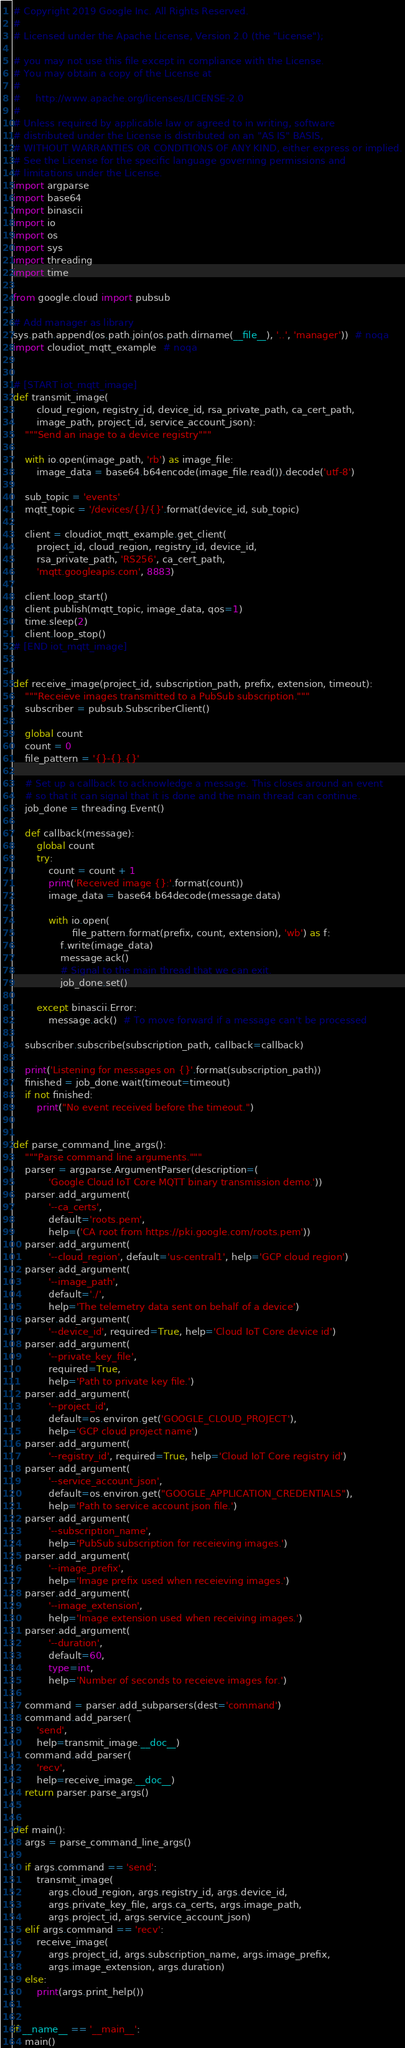Convert code to text. <code><loc_0><loc_0><loc_500><loc_500><_Python_># Copyright 2019 Google Inc. All Rights Reserved.
#
# Licensed under the Apache License, Version 2.0 (the "License");

# you may not use this file except in compliance with the License.
# You may obtain a copy of the License at
#
#     http://www.apache.org/licenses/LICENSE-2.0
#
# Unless required by applicable law or agreed to in writing, software
# distributed under the License is distributed on an "AS IS" BASIS,
# WITHOUT WARRANTIES OR CONDITIONS OF ANY KIND, either express or implied.
# See the License for the specific language governing permissions and
# limitations under the License.
import argparse
import base64
import binascii
import io
import os
import sys
import threading
import time

from google.cloud import pubsub

# Add manager as library
sys.path.append(os.path.join(os.path.dirname(__file__), '..', 'manager'))  # noqa
import cloudiot_mqtt_example  # noqa


# [START iot_mqtt_image]
def transmit_image(
        cloud_region, registry_id, device_id, rsa_private_path, ca_cert_path,
        image_path, project_id, service_account_json):
    """Send an inage to a device registry"""

    with io.open(image_path, 'rb') as image_file:
        image_data = base64.b64encode(image_file.read()).decode('utf-8')

    sub_topic = 'events'
    mqtt_topic = '/devices/{}/{}'.format(device_id, sub_topic)

    client = cloudiot_mqtt_example.get_client(
        project_id, cloud_region, registry_id, device_id,
        rsa_private_path, 'RS256', ca_cert_path,
        'mqtt.googleapis.com', 8883)

    client.loop_start()
    client.publish(mqtt_topic, image_data, qos=1)
    time.sleep(2)
    client.loop_stop()
# [END iot_mqtt_image]


def receive_image(project_id, subscription_path, prefix, extension, timeout):
    """Receieve images transmitted to a PubSub subscription."""
    subscriber = pubsub.SubscriberClient()

    global count
    count = 0
    file_pattern = '{}-{}.{}'

    # Set up a callback to acknowledge a message. This closes around an event
    # so that it can signal that it is done and the main thread can continue.
    job_done = threading.Event()

    def callback(message):
        global count
        try:
            count = count + 1
            print('Received image {}:'.format(count))
            image_data = base64.b64decode(message.data)

            with io.open(
                    file_pattern.format(prefix, count, extension), 'wb') as f:
                f.write(image_data)
                message.ack()
                # Signal to the main thread that we can exit.
                job_done.set()

        except binascii.Error:
            message.ack()  # To move forward if a message can't be processed

    subscriber.subscribe(subscription_path, callback=callback)

    print('Listening for messages on {}'.format(subscription_path))
    finished = job_done.wait(timeout=timeout)
    if not finished:
        print("No event received before the timeout.")


def parse_command_line_args():
    """Parse command line arguments."""
    parser = argparse.ArgumentParser(description=(
            'Google Cloud IoT Core MQTT binary transmission demo.'))
    parser.add_argument(
            '--ca_certs',
            default='roots.pem',
            help=('CA root from https://pki.google.com/roots.pem'))
    parser.add_argument(
            '--cloud_region', default='us-central1', help='GCP cloud region')
    parser.add_argument(
            '--image_path',
            default='./',
            help='The telemetry data sent on behalf of a device')
    parser.add_argument(
            '--device_id', required=True, help='Cloud IoT Core device id')
    parser.add_argument(
            '--private_key_file',
            required=True,
            help='Path to private key file.')
    parser.add_argument(
            '--project_id',
            default=os.environ.get('GOOGLE_CLOUD_PROJECT'),
            help='GCP cloud project name')
    parser.add_argument(
            '--registry_id', required=True, help='Cloud IoT Core registry id')
    parser.add_argument(
            '--service_account_json',
            default=os.environ.get("GOOGLE_APPLICATION_CREDENTIALS"),
            help='Path to service account json file.')
    parser.add_argument(
            '--subscription_name',
            help='PubSub subscription for receieving images.')
    parser.add_argument(
            '--image_prefix',
            help='Image prefix used when receieving images.')
    parser.add_argument(
            '--image_extension',
            help='Image extension used when receiving images.')
    parser.add_argument(
            '--duration',
            default=60,
            type=int,
            help='Number of seconds to receieve images for.')

    command = parser.add_subparsers(dest='command')
    command.add_parser(
        'send',
        help=transmit_image.__doc__)
    command.add_parser(
        'recv',
        help=receive_image.__doc__)
    return parser.parse_args()


def main():
    args = parse_command_line_args()

    if args.command == 'send':
        transmit_image(
            args.cloud_region, args.registry_id, args.device_id,
            args.private_key_file, args.ca_certs, args.image_path,
            args.project_id, args.service_account_json)
    elif args.command == 'recv':
        receive_image(
            args.project_id, args.subscription_name, args.image_prefix,
            args.image_extension, args.duration)
    else:
        print(args.print_help())


if __name__ == '__main__':
    main()
</code> 